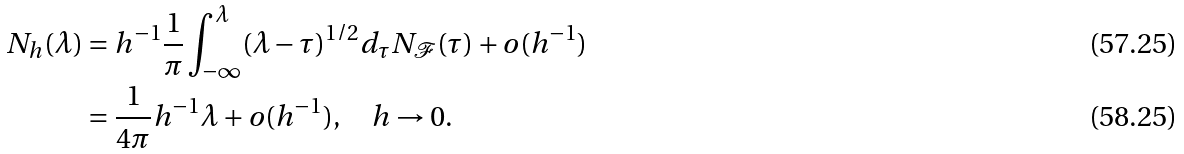Convert formula to latex. <formula><loc_0><loc_0><loc_500><loc_500>N _ { h } ( \lambda ) & = h ^ { - 1 } \frac { 1 } { \pi } \int _ { - \infty } ^ { \lambda } ( \lambda - \tau ) ^ { 1 / 2 } d _ { \tau } N _ { \mathcal { F } } ( \tau ) + o ( h ^ { - 1 } ) \\ & = \frac { 1 } { 4 \pi } h ^ { - 1 } \lambda + o ( h ^ { - 1 } ) , \quad h \rightarrow 0 .</formula> 